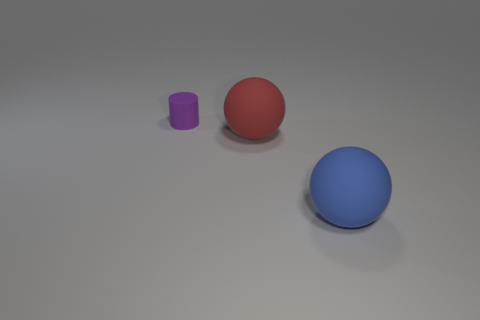Add 2 green cubes. How many objects exist? 5 Subtract 1 cylinders. How many cylinders are left? 0 Subtract all blue cylinders. Subtract all blue cubes. How many cylinders are left? 1 Subtract all gray things. Subtract all cylinders. How many objects are left? 2 Add 2 large blue matte objects. How many large blue matte objects are left? 3 Add 3 small gray balls. How many small gray balls exist? 3 Subtract 0 green cylinders. How many objects are left? 3 Subtract all cylinders. How many objects are left? 2 Subtract all red blocks. How many red balls are left? 1 